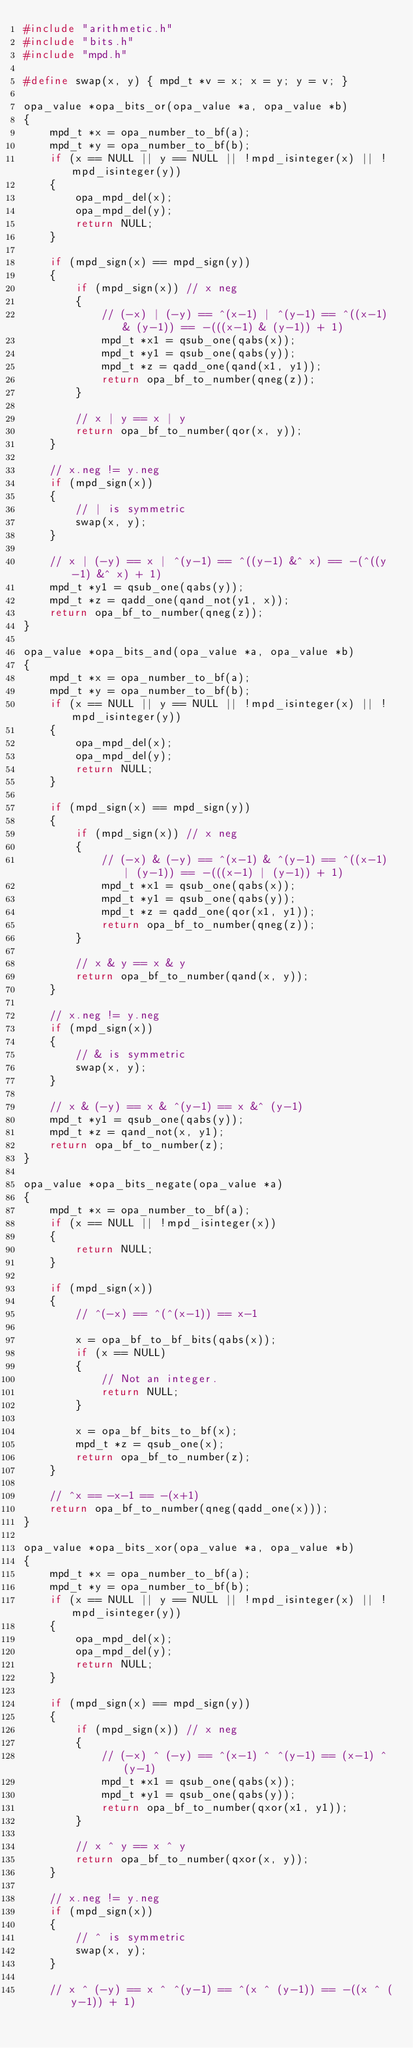Convert code to text. <code><loc_0><loc_0><loc_500><loc_500><_C_>#include "arithmetic.h"
#include "bits.h"
#include "mpd.h"

#define swap(x, y) { mpd_t *v = x; x = y; y = v; }

opa_value *opa_bits_or(opa_value *a, opa_value *b)
{
    mpd_t *x = opa_number_to_bf(a);
    mpd_t *y = opa_number_to_bf(b);
    if (x == NULL || y == NULL || !mpd_isinteger(x) || !mpd_isinteger(y))
    {
        opa_mpd_del(x);
        opa_mpd_del(y);
        return NULL;
    }

    if (mpd_sign(x) == mpd_sign(y))
    {
        if (mpd_sign(x)) // x neg
        {
            // (-x) | (-y) == ^(x-1) | ^(y-1) == ^((x-1) & (y-1)) == -(((x-1) & (y-1)) + 1)
            mpd_t *x1 = qsub_one(qabs(x));
            mpd_t *y1 = qsub_one(qabs(y));
            mpd_t *z = qadd_one(qand(x1, y1));
            return opa_bf_to_number(qneg(z));
        }

        // x | y == x | y
        return opa_bf_to_number(qor(x, y));
    }

    // x.neg != y.neg
    if (mpd_sign(x))
    {
        // | is symmetric
        swap(x, y);
    }

    // x | (-y) == x | ^(y-1) == ^((y-1) &^ x) == -(^((y-1) &^ x) + 1)
    mpd_t *y1 = qsub_one(qabs(y));
    mpd_t *z = qadd_one(qand_not(y1, x));
    return opa_bf_to_number(qneg(z));
}

opa_value *opa_bits_and(opa_value *a, opa_value *b)
{
    mpd_t *x = opa_number_to_bf(a);
    mpd_t *y = opa_number_to_bf(b);
    if (x == NULL || y == NULL || !mpd_isinteger(x) || !mpd_isinteger(y))
    {
        opa_mpd_del(x);
        opa_mpd_del(y);
        return NULL;
    }

    if (mpd_sign(x) == mpd_sign(y))
    {
        if (mpd_sign(x)) // x neg
        {
            // (-x) & (-y) == ^(x-1) & ^(y-1) == ^((x-1) | (y-1)) == -(((x-1) | (y-1)) + 1)
            mpd_t *x1 = qsub_one(qabs(x));
            mpd_t *y1 = qsub_one(qabs(y));
            mpd_t *z = qadd_one(qor(x1, y1));
            return opa_bf_to_number(qneg(z));
        }

        // x & y == x & y
        return opa_bf_to_number(qand(x, y));
    }

    // x.neg != y.neg
    if (mpd_sign(x))
    {
        // & is symmetric
        swap(x, y);
    }

    // x & (-y) == x & ^(y-1) == x &^ (y-1)
    mpd_t *y1 = qsub_one(qabs(y));
    mpd_t *z = qand_not(x, y1);
    return opa_bf_to_number(z);
}

opa_value *opa_bits_negate(opa_value *a)
{
    mpd_t *x = opa_number_to_bf(a);
    if (x == NULL || !mpd_isinteger(x))
    {
        return NULL;
    }

    if (mpd_sign(x))
    {
        // ^(-x) == ^(^(x-1)) == x-1

        x = opa_bf_to_bf_bits(qabs(x));
        if (x == NULL)
        {
            // Not an integer.
            return NULL;
        }

        x = opa_bf_bits_to_bf(x);
        mpd_t *z = qsub_one(x);
        return opa_bf_to_number(z);
    }

    // ^x == -x-1 == -(x+1)
    return opa_bf_to_number(qneg(qadd_one(x)));
}

opa_value *opa_bits_xor(opa_value *a, opa_value *b)
{
    mpd_t *x = opa_number_to_bf(a);
    mpd_t *y = opa_number_to_bf(b);
    if (x == NULL || y == NULL || !mpd_isinteger(x) || !mpd_isinteger(y))
    {
        opa_mpd_del(x);
        opa_mpd_del(y);
        return NULL;
    }

    if (mpd_sign(x) == mpd_sign(y))
    {
        if (mpd_sign(x)) // x neg
        {
            // (-x) ^ (-y) == ^(x-1) ^ ^(y-1) == (x-1) ^ (y-1)
            mpd_t *x1 = qsub_one(qabs(x));
            mpd_t *y1 = qsub_one(qabs(y));
            return opa_bf_to_number(qxor(x1, y1));
        }

        // x ^ y == x ^ y
        return opa_bf_to_number(qxor(x, y));
    }

    // x.neg != y.neg
    if (mpd_sign(x))
    {
        // ^ is symmetric
        swap(x, y);
    }

    // x ^ (-y) == x ^ ^(y-1) == ^(x ^ (y-1)) == -((x ^ (y-1)) + 1)</code> 